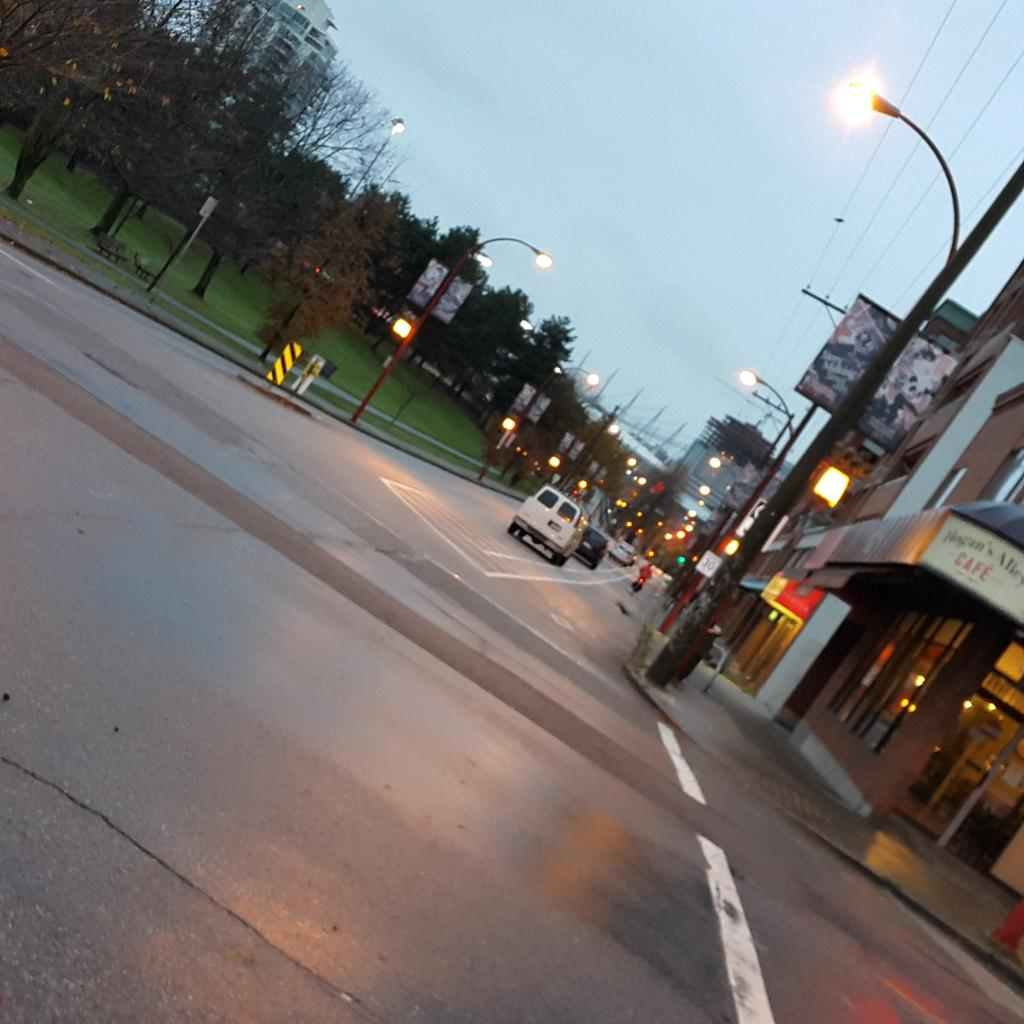What types of objects can be seen in the image? There are vehicles and lights visible in the image. What can be seen on the left side of the image? There are trees on the left side of the image. What is on the right side of the image? There are buildings on the right side of the image. What is visible at the top of the image? The sky is visible at the top of the image. What type of statement can be seen written on the doll in the image? There is no doll present in the image, so no statement can be seen written on it. How many bags of popcorn are visible in the image? There is no popcorn present in the image. 